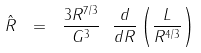<formula> <loc_0><loc_0><loc_500><loc_500>\hat { R } \ = \ \frac { 3 R ^ { 7 / 3 } } { G ^ { 3 } } \ \frac { d } { d R } \left ( \frac { L } { R ^ { 4 / 3 } } \right )</formula> 